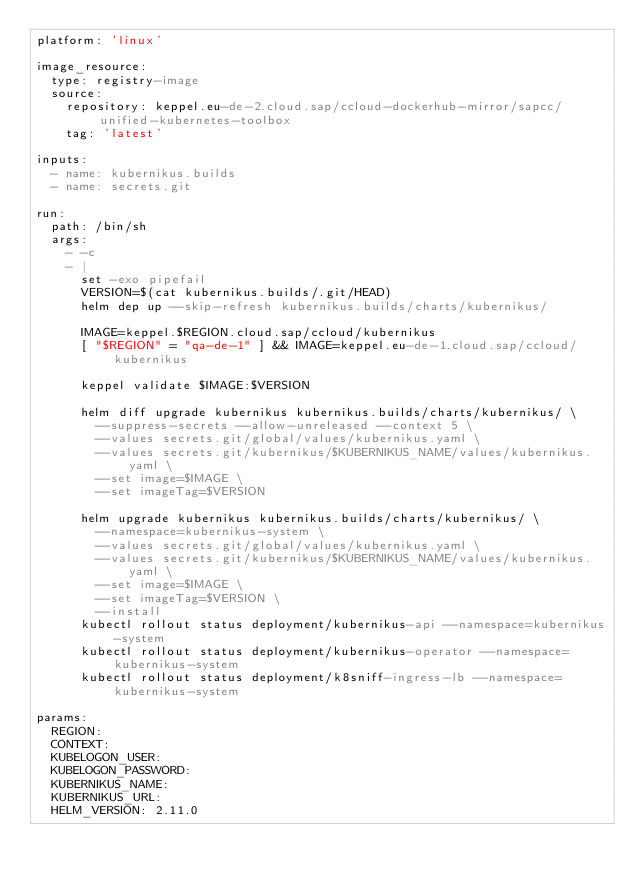<code> <loc_0><loc_0><loc_500><loc_500><_YAML_>platform: 'linux'

image_resource:
  type: registry-image
  source:
    repository: keppel.eu-de-2.cloud.sap/ccloud-dockerhub-mirror/sapcc/unified-kubernetes-toolbox
    tag: 'latest'

inputs:
  - name: kubernikus.builds
  - name: secrets.git

run:
  path: /bin/sh
  args:
    - -c
    - |
      set -exo pipefail
      VERSION=$(cat kubernikus.builds/.git/HEAD)
      helm dep up --skip-refresh kubernikus.builds/charts/kubernikus/

      IMAGE=keppel.$REGION.cloud.sap/ccloud/kubernikus
      [ "$REGION" = "qa-de-1" ] && IMAGE=keppel.eu-de-1.cloud.sap/ccloud/kubernikus

      keppel validate $IMAGE:$VERSION

      helm diff upgrade kubernikus kubernikus.builds/charts/kubernikus/ \
        --suppress-secrets --allow-unreleased --context 5 \
        --values secrets.git/global/values/kubernikus.yaml \
        --values secrets.git/kubernikus/$KUBERNIKUS_NAME/values/kubernikus.yaml \
        --set image=$IMAGE \
        --set imageTag=$VERSION

      helm upgrade kubernikus kubernikus.builds/charts/kubernikus/ \
        --namespace=kubernikus-system \
        --values secrets.git/global/values/kubernikus.yaml \
        --values secrets.git/kubernikus/$KUBERNIKUS_NAME/values/kubernikus.yaml \
        --set image=$IMAGE \
        --set imageTag=$VERSION \
        --install
      kubectl rollout status deployment/kubernikus-api --namespace=kubernikus-system
      kubectl rollout status deployment/kubernikus-operator --namespace=kubernikus-system
      kubectl rollout status deployment/k8sniff-ingress-lb --namespace=kubernikus-system

params:
  REGION:
  CONTEXT:
  KUBELOGON_USER:
  KUBELOGON_PASSWORD:
  KUBERNIKUS_NAME:
  KUBERNIKUS_URL:
  HELM_VERSION: 2.11.0
</code> 